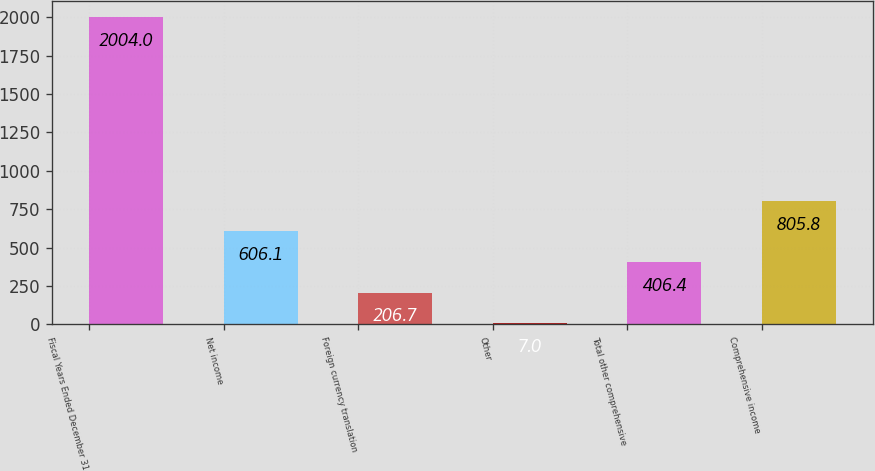<chart> <loc_0><loc_0><loc_500><loc_500><bar_chart><fcel>Fiscal Years Ended December 31<fcel>Net income<fcel>Foreign currency translation<fcel>Other<fcel>Total other comprehensive<fcel>Comprehensive income<nl><fcel>2004<fcel>606.1<fcel>206.7<fcel>7<fcel>406.4<fcel>805.8<nl></chart> 